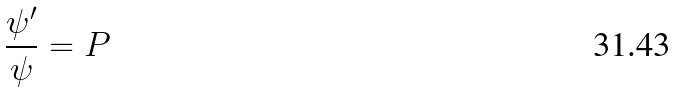<formula> <loc_0><loc_0><loc_500><loc_500>\frac { \psi ^ { \prime } } { \psi } = P</formula> 